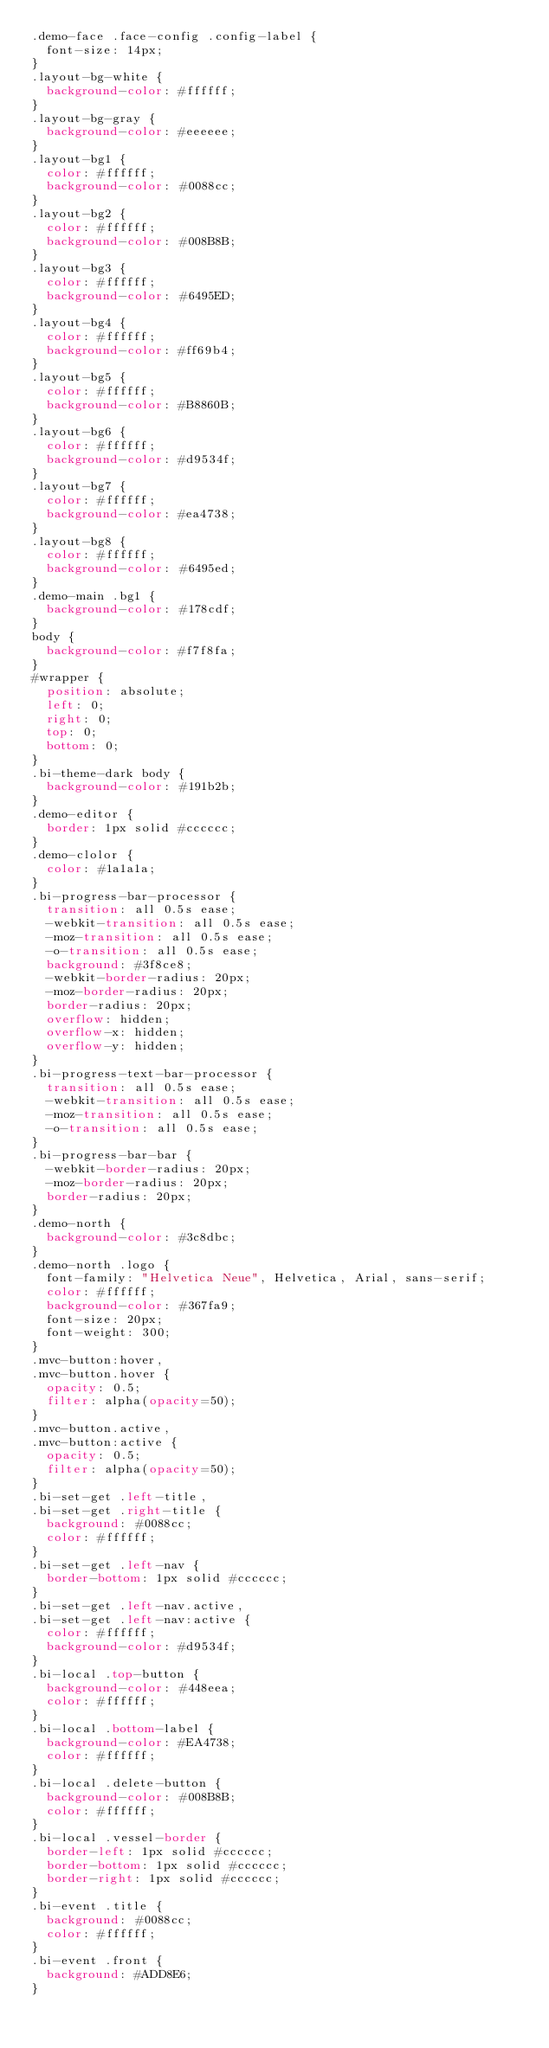<code> <loc_0><loc_0><loc_500><loc_500><_CSS_>.demo-face .face-config .config-label {
  font-size: 14px;
}
.layout-bg-white {
  background-color: #ffffff;
}
.layout-bg-gray {
  background-color: #eeeeee;
}
.layout-bg1 {
  color: #ffffff;
  background-color: #0088cc;
}
.layout-bg2 {
  color: #ffffff;
  background-color: #008B8B;
}
.layout-bg3 {
  color: #ffffff;
  background-color: #6495ED;
}
.layout-bg4 {
  color: #ffffff;
  background-color: #ff69b4;
}
.layout-bg5 {
  color: #ffffff;
  background-color: #B8860B;
}
.layout-bg6 {
  color: #ffffff;
  background-color: #d9534f;
}
.layout-bg7 {
  color: #ffffff;
  background-color: #ea4738;
}
.layout-bg8 {
  color: #ffffff;
  background-color: #6495ed;
}
.demo-main .bg1 {
  background-color: #178cdf;
}
body {
  background-color: #f7f8fa;
}
#wrapper {
  position: absolute;
  left: 0;
  right: 0;
  top: 0;
  bottom: 0;
}
.bi-theme-dark body {
  background-color: #191b2b;
}
.demo-editor {
  border: 1px solid #cccccc;
}
.demo-clolor {
  color: #1a1a1a;
}
.bi-progress-bar-processor {
  transition: all 0.5s ease;
  -webkit-transition: all 0.5s ease;
  -moz-transition: all 0.5s ease;
  -o-transition: all 0.5s ease;
  background: #3f8ce8;
  -webkit-border-radius: 20px;
  -moz-border-radius: 20px;
  border-radius: 20px;
  overflow: hidden;
  overflow-x: hidden;
  overflow-y: hidden;
}
.bi-progress-text-bar-processor {
  transition: all 0.5s ease;
  -webkit-transition: all 0.5s ease;
  -moz-transition: all 0.5s ease;
  -o-transition: all 0.5s ease;
}
.bi-progress-bar-bar {
  -webkit-border-radius: 20px;
  -moz-border-radius: 20px;
  border-radius: 20px;
}
.demo-north {
  background-color: #3c8dbc;
}
.demo-north .logo {
  font-family: "Helvetica Neue", Helvetica, Arial, sans-serif;
  color: #ffffff;
  background-color: #367fa9;
  font-size: 20px;
  font-weight: 300;
}
.mvc-button:hover,
.mvc-button.hover {
  opacity: 0.5;
  filter: alpha(opacity=50);
}
.mvc-button.active,
.mvc-button:active {
  opacity: 0.5;
  filter: alpha(opacity=50);
}
.bi-set-get .left-title,
.bi-set-get .right-title {
  background: #0088cc;
  color: #ffffff;
}
.bi-set-get .left-nav {
  border-bottom: 1px solid #cccccc;
}
.bi-set-get .left-nav.active,
.bi-set-get .left-nav:active {
  color: #ffffff;
  background-color: #d9534f;
}
.bi-local .top-button {
  background-color: #448eea;
  color: #ffffff;
}
.bi-local .bottom-label {
  background-color: #EA4738;
  color: #ffffff;
}
.bi-local .delete-button {
  background-color: #008B8B;
  color: #ffffff;
}
.bi-local .vessel-border {
  border-left: 1px solid #cccccc;
  border-bottom: 1px solid #cccccc;
  border-right: 1px solid #cccccc;
}
.bi-event .title {
  background: #0088cc;
  color: #ffffff;
}
.bi-event .front {
  background: #ADD8E6;
}</code> 